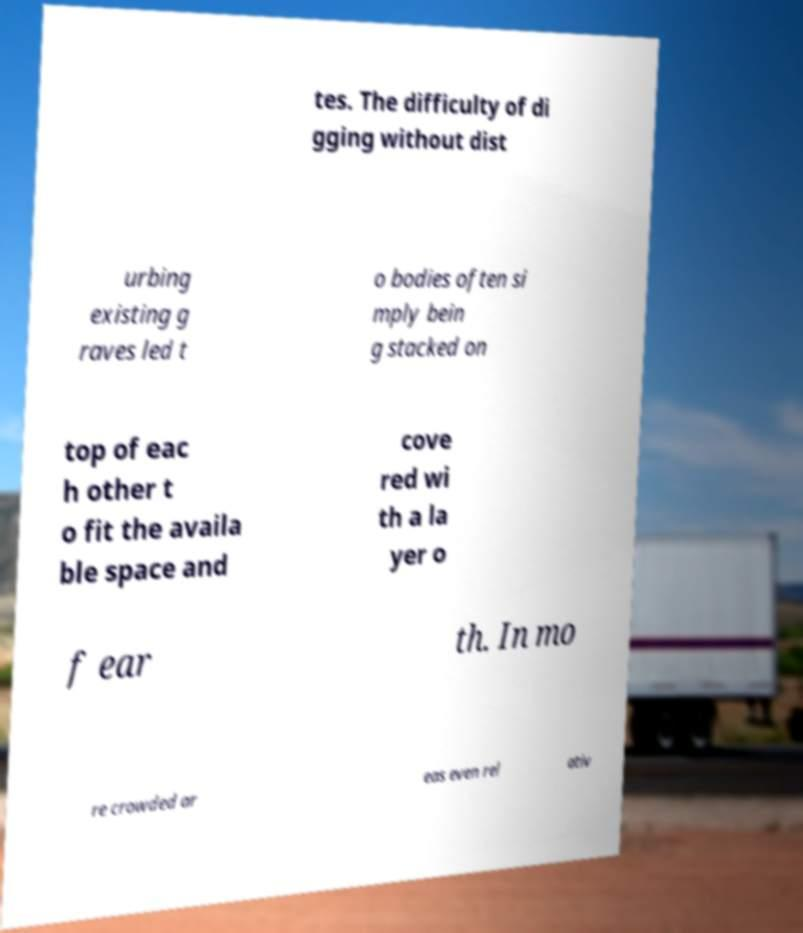Can you accurately transcribe the text from the provided image for me? tes. The difficulty of di gging without dist urbing existing g raves led t o bodies often si mply bein g stacked on top of eac h other t o fit the availa ble space and cove red wi th a la yer o f ear th. In mo re crowded ar eas even rel ativ 